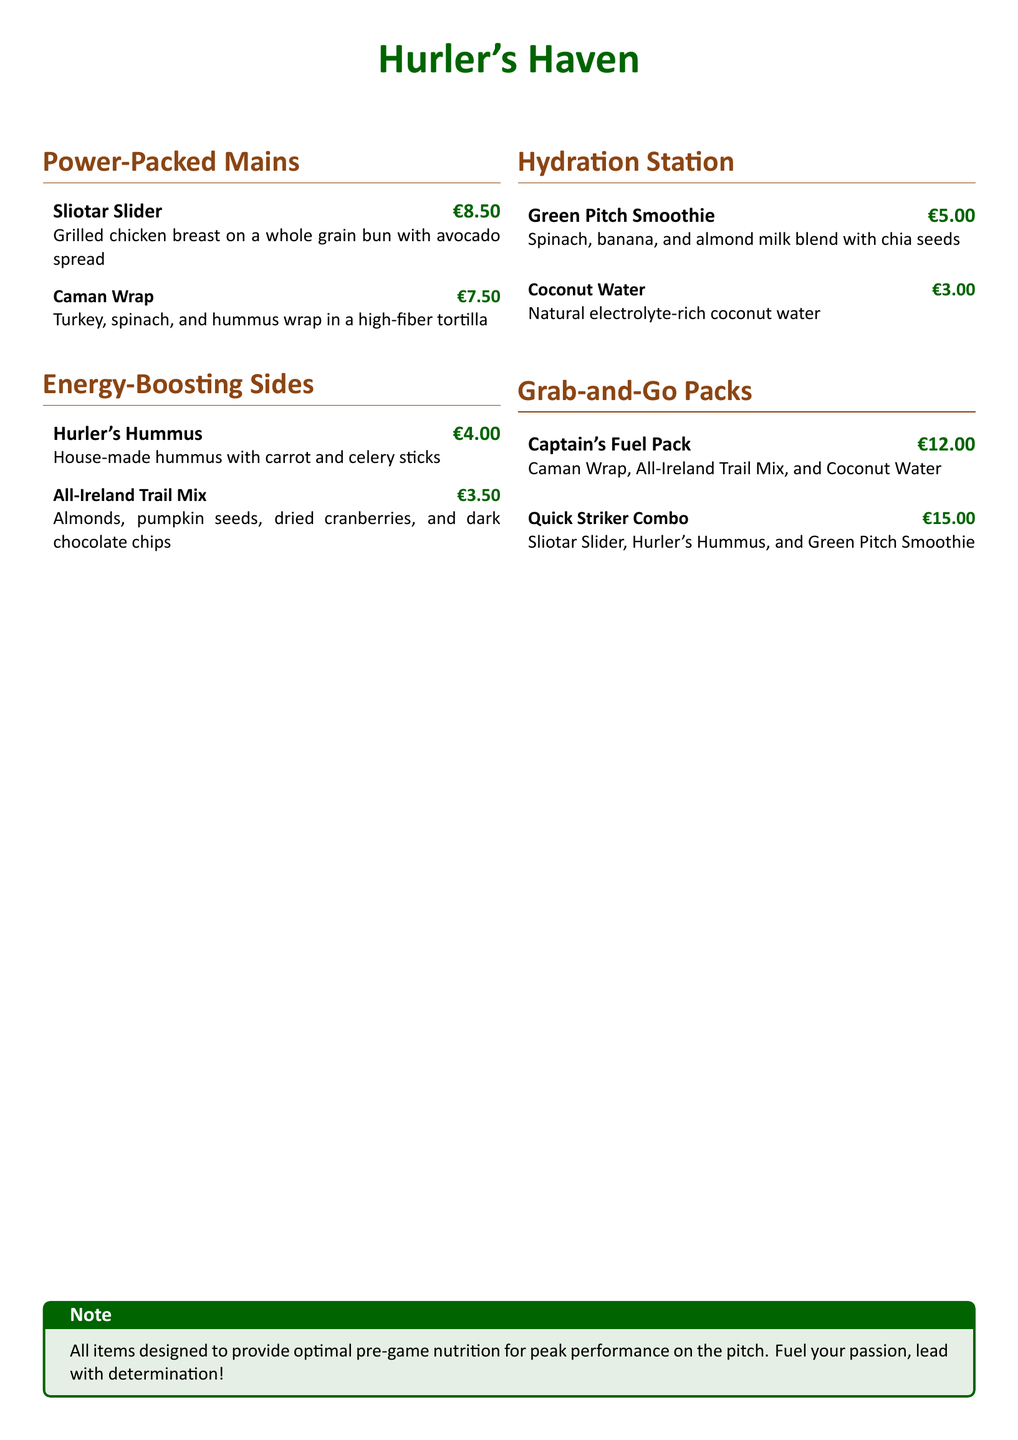What is the price of a Sliotar Slider? The price of a Sliotar Slider is listed in the menu under Power-Packed Mains.
Answer: €8.50 How many items are listed under Energy-Boosting Sides? The document lists a total of two items under Energy-Boosting Sides.
Answer: 2 What is included in the Captain's Fuel Pack? The Captain's Fuel Pack consists of a Caman Wrap, All-Ireland Trail Mix, and Coconut Water.
Answer: Caman Wrap, All-Ireland Trail Mix, Coconut Water What type of drink is the Green Pitch Smoothie? The Green Pitch Smoothie is a smoothie made from spinach, banana, and almond milk blend with chia seeds.
Answer: Smoothie What is the total price of the Quick Striker Combo? The Quick Striker Combo is priced at €15.00, as indicated in the Grab-and-Go Packs section.
Answer: €15.00 Which side is made with house-made hummus? The side made with house-made hummus is listed as Hurler's Hummus.
Answer: Hurler's Hummus What section includes the Coconut Water? The Coconut Water is included in the Hydration Station section of the menu.
Answer: Hydration Station What is the purpose of the items on the menu? The items are designed to provide optimal pre-game nutrition for peak performance on the pitch.
Answer: Optimal pre-game nutrition 